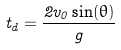Convert formula to latex. <formula><loc_0><loc_0><loc_500><loc_500>t _ { d } = \frac { 2 v _ { 0 } \sin ( \theta ) } { g }</formula> 